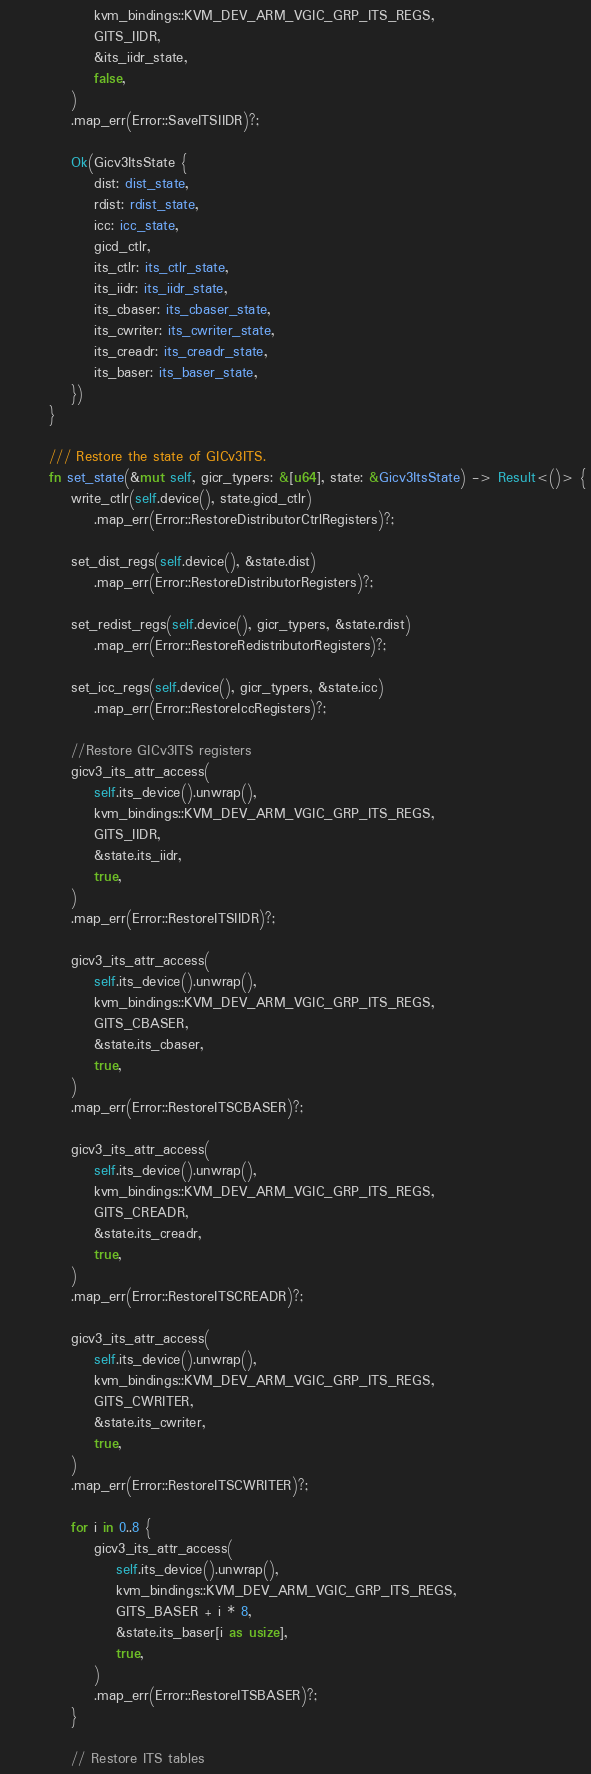Convert code to text. <code><loc_0><loc_0><loc_500><loc_500><_Rust_>                kvm_bindings::KVM_DEV_ARM_VGIC_GRP_ITS_REGS,
                GITS_IIDR,
                &its_iidr_state,
                false,
            )
            .map_err(Error::SaveITSIIDR)?;

            Ok(Gicv3ItsState {
                dist: dist_state,
                rdist: rdist_state,
                icc: icc_state,
                gicd_ctlr,
                its_ctlr: its_ctlr_state,
                its_iidr: its_iidr_state,
                its_cbaser: its_cbaser_state,
                its_cwriter: its_cwriter_state,
                its_creadr: its_creadr_state,
                its_baser: its_baser_state,
            })
        }

        /// Restore the state of GICv3ITS.
        fn set_state(&mut self, gicr_typers: &[u64], state: &Gicv3ItsState) -> Result<()> {
            write_ctlr(self.device(), state.gicd_ctlr)
                .map_err(Error::RestoreDistributorCtrlRegisters)?;

            set_dist_regs(self.device(), &state.dist)
                .map_err(Error::RestoreDistributorRegisters)?;

            set_redist_regs(self.device(), gicr_typers, &state.rdist)
                .map_err(Error::RestoreRedistributorRegisters)?;

            set_icc_regs(self.device(), gicr_typers, &state.icc)
                .map_err(Error::RestoreIccRegisters)?;

            //Restore GICv3ITS registers
            gicv3_its_attr_access(
                self.its_device().unwrap(),
                kvm_bindings::KVM_DEV_ARM_VGIC_GRP_ITS_REGS,
                GITS_IIDR,
                &state.its_iidr,
                true,
            )
            .map_err(Error::RestoreITSIIDR)?;

            gicv3_its_attr_access(
                self.its_device().unwrap(),
                kvm_bindings::KVM_DEV_ARM_VGIC_GRP_ITS_REGS,
                GITS_CBASER,
                &state.its_cbaser,
                true,
            )
            .map_err(Error::RestoreITSCBASER)?;

            gicv3_its_attr_access(
                self.its_device().unwrap(),
                kvm_bindings::KVM_DEV_ARM_VGIC_GRP_ITS_REGS,
                GITS_CREADR,
                &state.its_creadr,
                true,
            )
            .map_err(Error::RestoreITSCREADR)?;

            gicv3_its_attr_access(
                self.its_device().unwrap(),
                kvm_bindings::KVM_DEV_ARM_VGIC_GRP_ITS_REGS,
                GITS_CWRITER,
                &state.its_cwriter,
                true,
            )
            .map_err(Error::RestoreITSCWRITER)?;

            for i in 0..8 {
                gicv3_its_attr_access(
                    self.its_device().unwrap(),
                    kvm_bindings::KVM_DEV_ARM_VGIC_GRP_ITS_REGS,
                    GITS_BASER + i * 8,
                    &state.its_baser[i as usize],
                    true,
                )
                .map_err(Error::RestoreITSBASER)?;
            }

            // Restore ITS tables</code> 